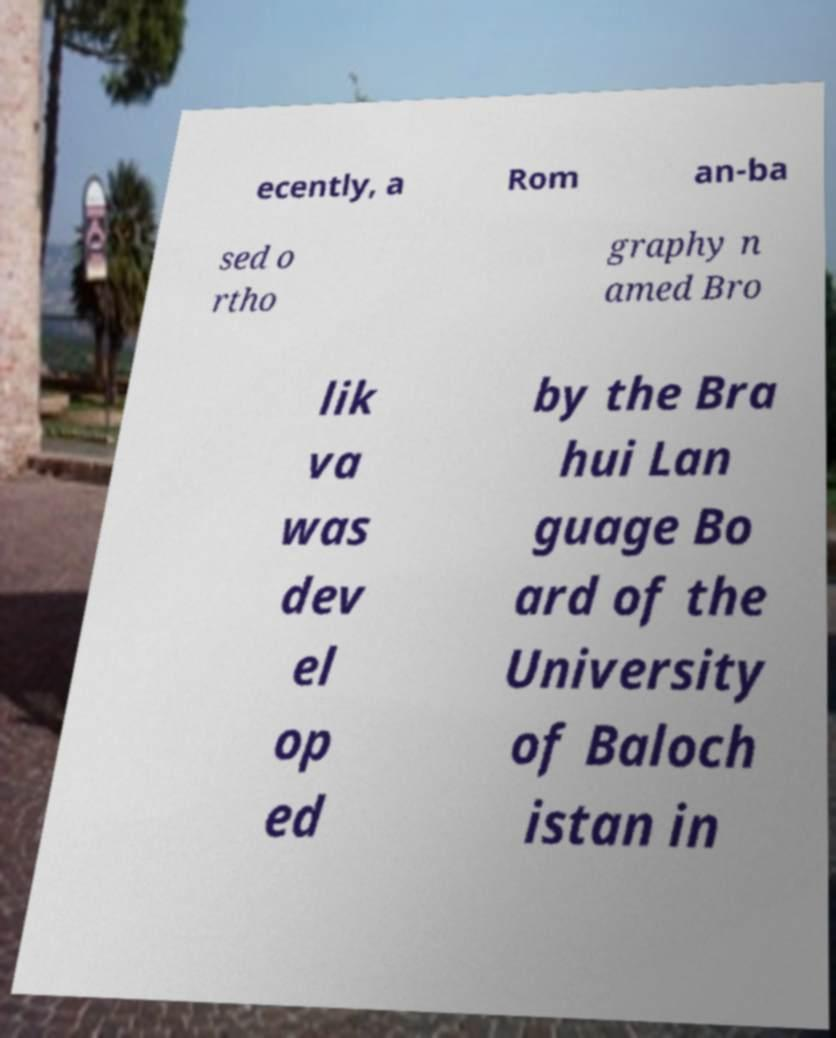There's text embedded in this image that I need extracted. Can you transcribe it verbatim? ecently, a Rom an-ba sed o rtho graphy n amed Bro lik va was dev el op ed by the Bra hui Lan guage Bo ard of the University of Baloch istan in 